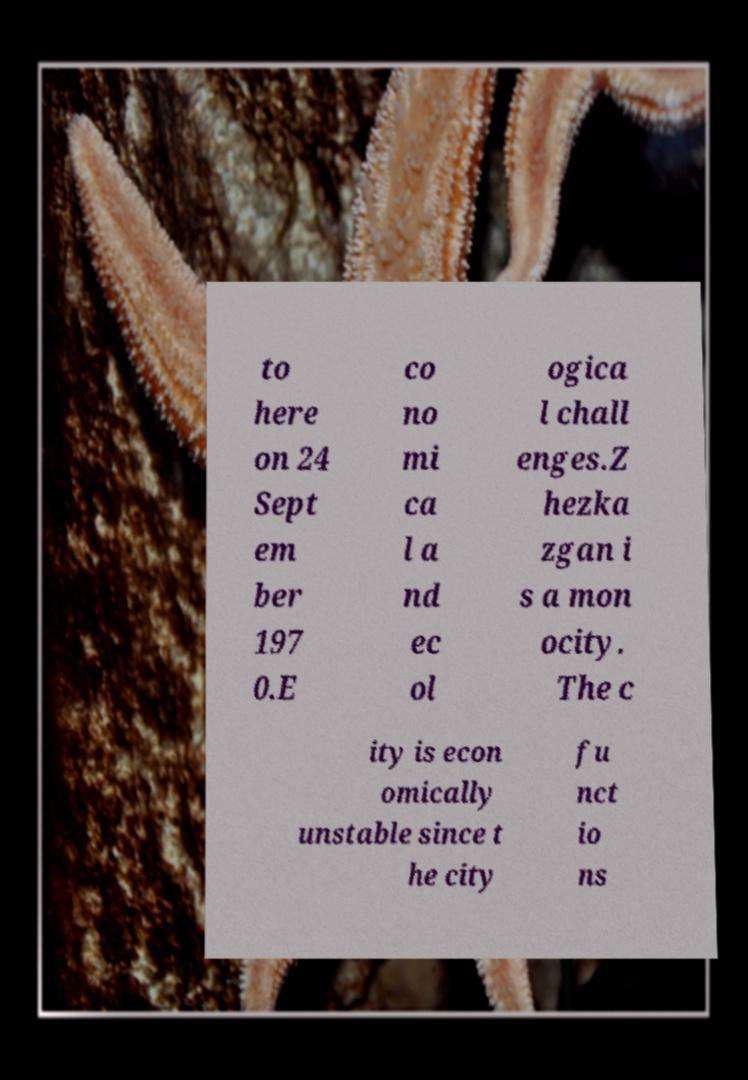For documentation purposes, I need the text within this image transcribed. Could you provide that? to here on 24 Sept em ber 197 0.E co no mi ca l a nd ec ol ogica l chall enges.Z hezka zgan i s a mon ocity. The c ity is econ omically unstable since t he city fu nct io ns 